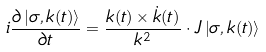Convert formula to latex. <formula><loc_0><loc_0><loc_500><loc_500>i \frac { \partial \left | \sigma , { k } ( t ) \right \rangle } { \partial t } = \frac { { k } ( t ) \times \dot { k } ( t ) } { k ^ { 2 } } \cdot { J } \left | \sigma , { k } ( t ) \right \rangle</formula> 